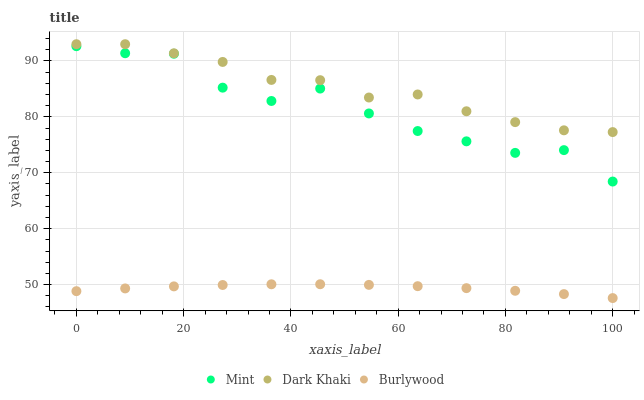Does Burlywood have the minimum area under the curve?
Answer yes or no. Yes. Does Dark Khaki have the maximum area under the curve?
Answer yes or no. Yes. Does Mint have the minimum area under the curve?
Answer yes or no. No. Does Mint have the maximum area under the curve?
Answer yes or no. No. Is Burlywood the smoothest?
Answer yes or no. Yes. Is Mint the roughest?
Answer yes or no. Yes. Is Mint the smoothest?
Answer yes or no. No. Is Burlywood the roughest?
Answer yes or no. No. Does Burlywood have the lowest value?
Answer yes or no. Yes. Does Mint have the lowest value?
Answer yes or no. No. Does Dark Khaki have the highest value?
Answer yes or no. Yes. Does Mint have the highest value?
Answer yes or no. No. Is Burlywood less than Mint?
Answer yes or no. Yes. Is Dark Khaki greater than Burlywood?
Answer yes or no. Yes. Does Burlywood intersect Mint?
Answer yes or no. No. 